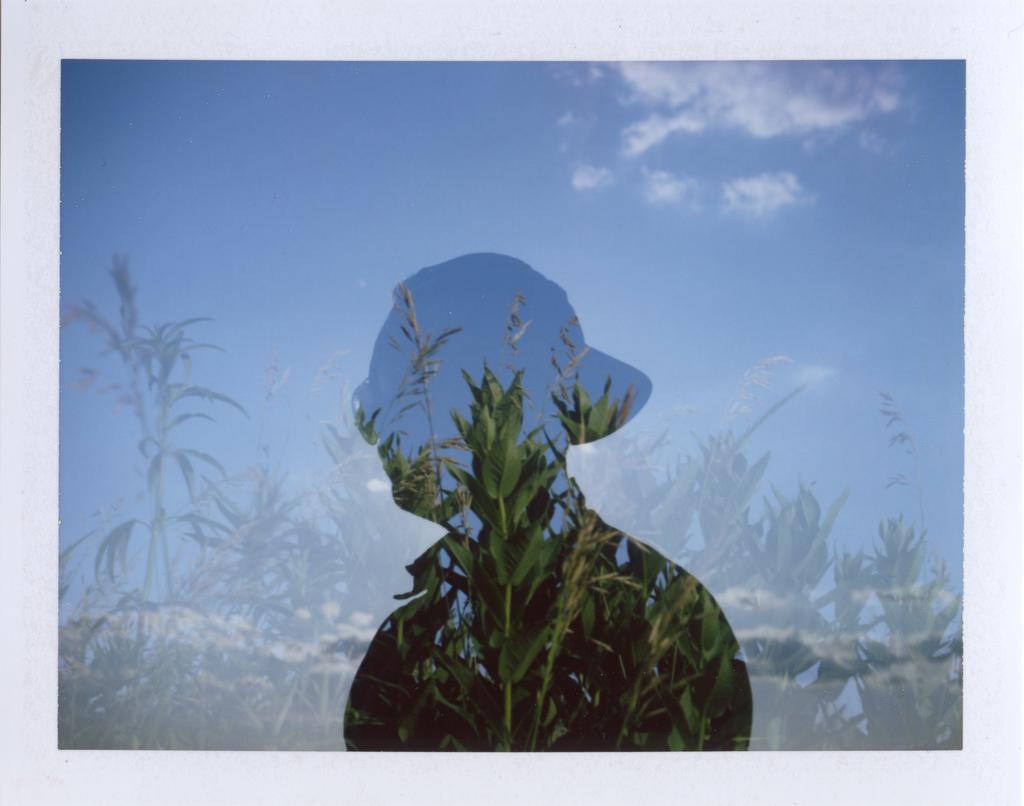What can be seen in the image that resembles a person? There is a shadow of a person in the image. What type of vegetation is present in the image? There are plants in the image. What is the condition of the sky in the image? The sky is clear in the image. What type of cork can be seen in the image? There is no cork present in the image. Is there a notebook visible in the image? There is no notebook visible in the image. 